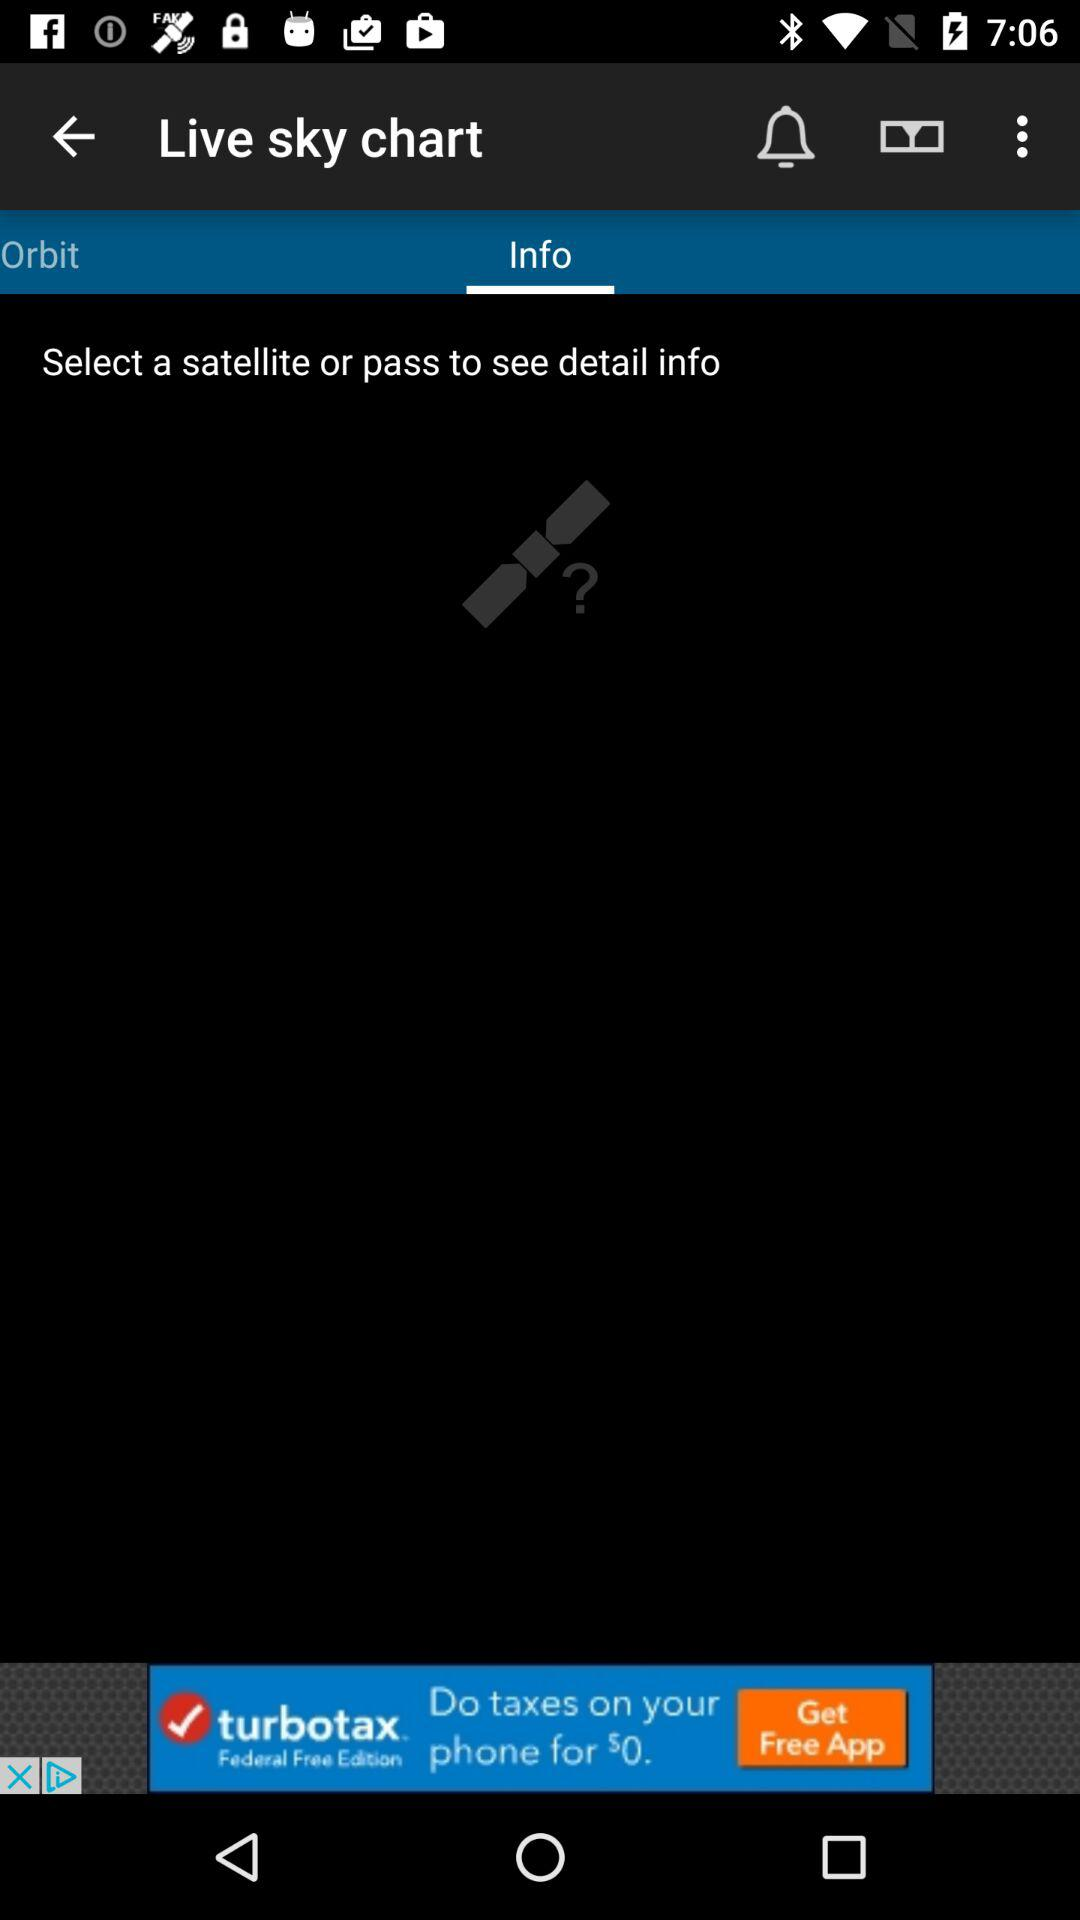What is the name of the application? The name of the application is "Live sky chart". 